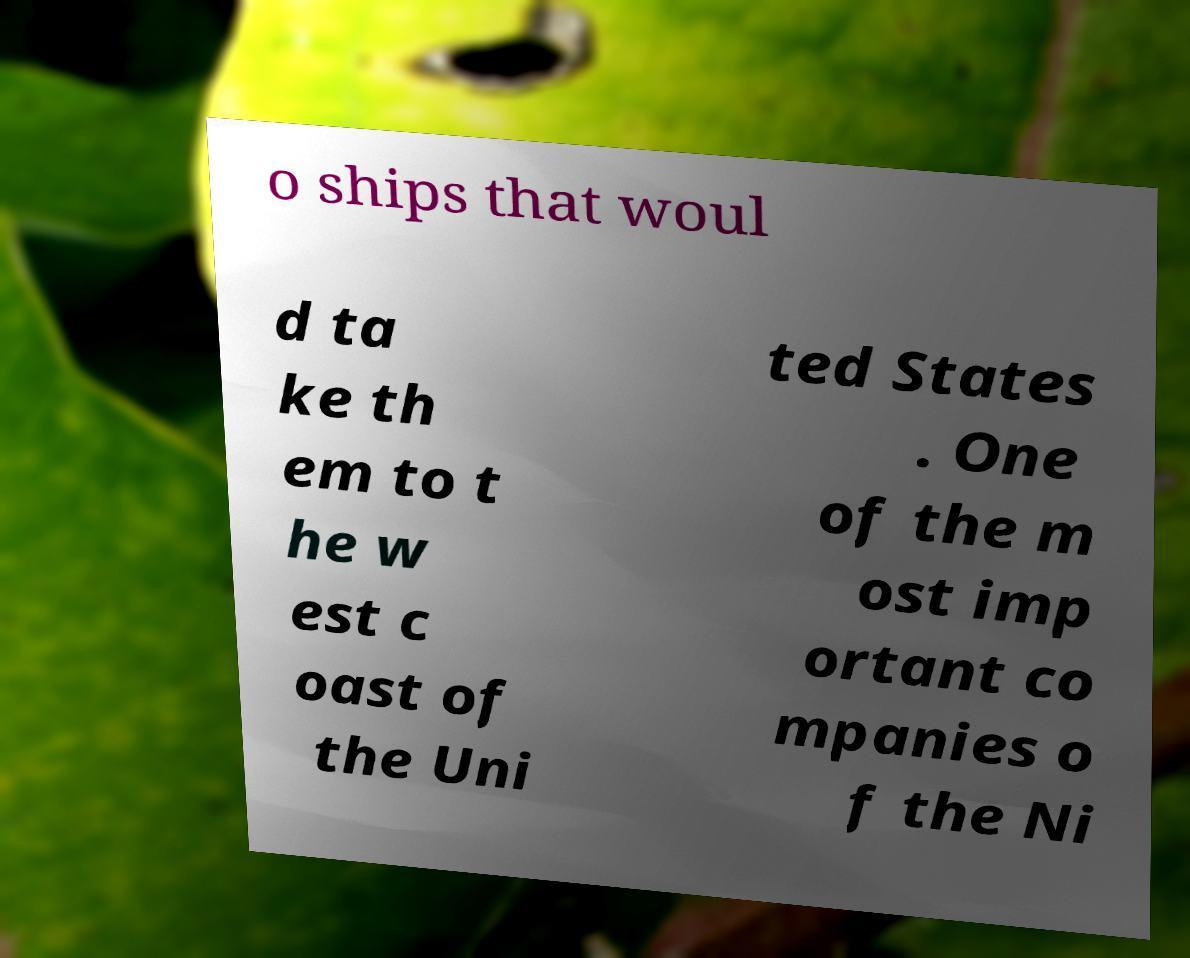For documentation purposes, I need the text within this image transcribed. Could you provide that? o ships that woul d ta ke th em to t he w est c oast of the Uni ted States . One of the m ost imp ortant co mpanies o f the Ni 